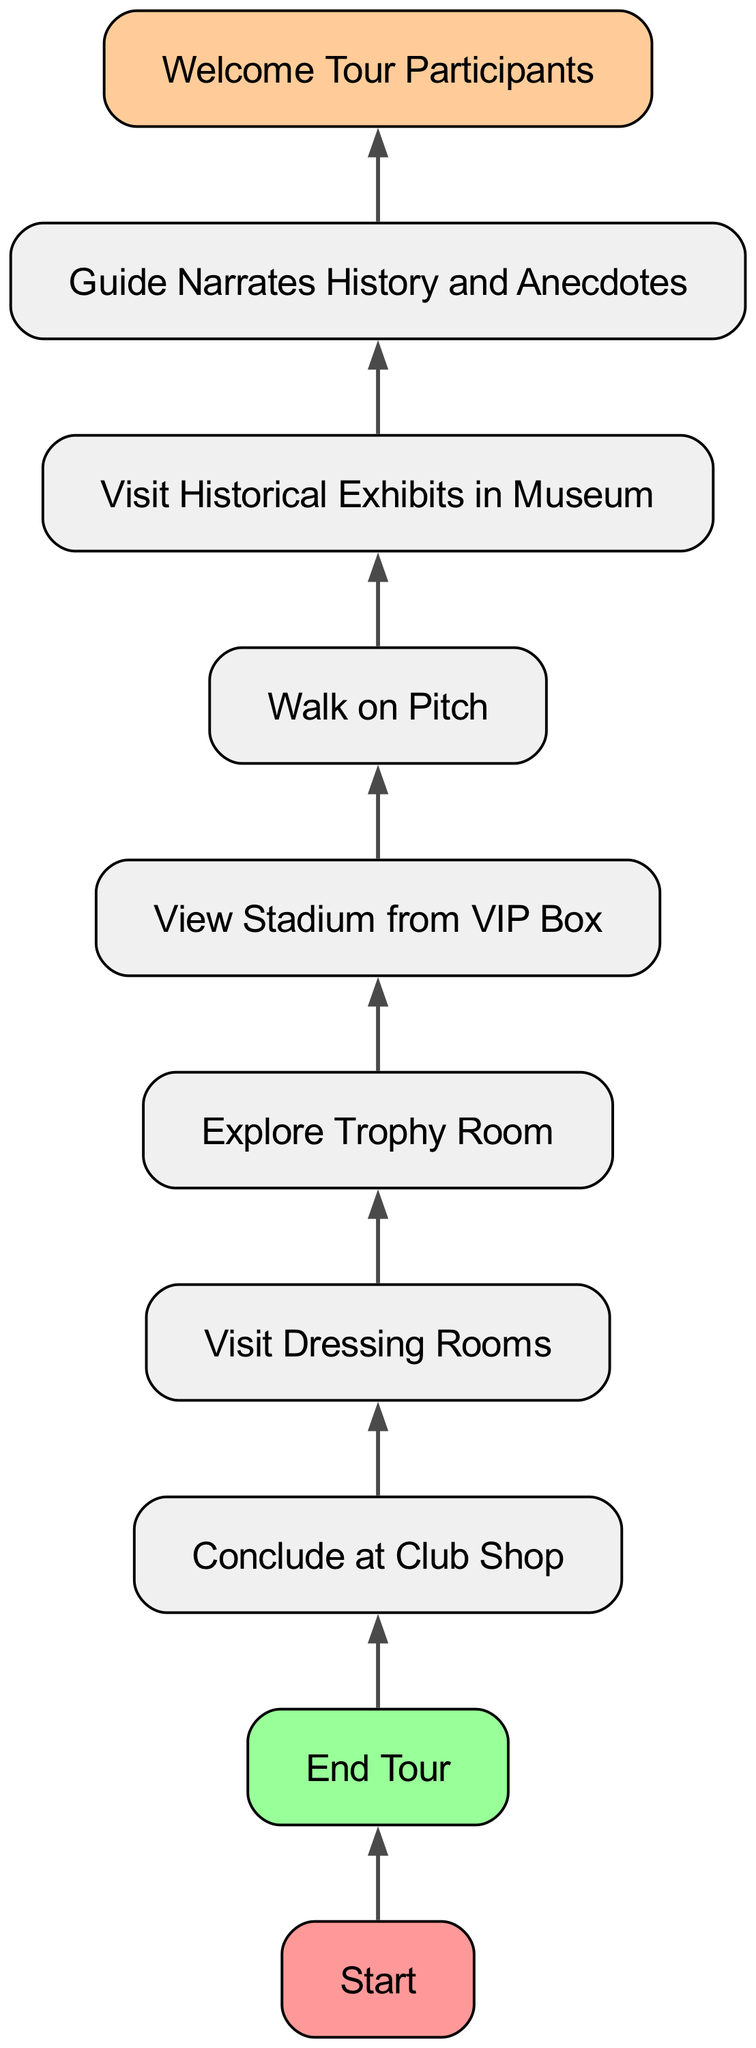What is the starting point of the tour? The diagram clearly indicates that the starting point of the tour is labeled as "Start."
Answer: Start How many nodes are there in the diagram? By counting all the unique nodes listed in the flowchart, we find a total of 9 nodes, including 'Start' and 'End Tour.'
Answer: 9 Which node follows 'Guide Narrates History and Anecdotes'? Looking at the directed flow of the diagram, it points out that 'Guide Narrates History and Anecdotes' leads to 'Welcome Tour Participants.'
Answer: Welcome Tour Participants What is the last step in the tour? The flowchart shows that after all activities, the process ends with the node labeled 'Conclude at Club Shop.'
Answer: Conclude at Club Shop What is the second step after the tour starts? By following the flow from 'Welcome Tour Participants,' the second step is to 'Guide Narrates History and Anecdotes.'
Answer: Guide Narrates History and Anecdotes What is the relationship between 'Walk on Pitch' and 'Visit Historical Exhibits in Museum'? The diagram shows a direct flow from 'Walk on Pitch' leading to 'Visit Historical Exhibits in Museum,' indicating 'Walk on Pitch' precedes the visit to the exhibits.
Answer: Walk on Pitch leads to Visit Historical Exhibits in Museum If the tour begins, which node comes immediately before 'End Tour'? Tracing the flow of the diagram, 'End Tour' immediately follows 'Conclude at Club Shop' indicating that it is the last action before the end.
Answer: Conclude at Club Shop What color is the start node? The diagram indicates that the 'Start' node is highlighted with the color '#ff9999,' making it visually distinct as red.
Answer: Red 